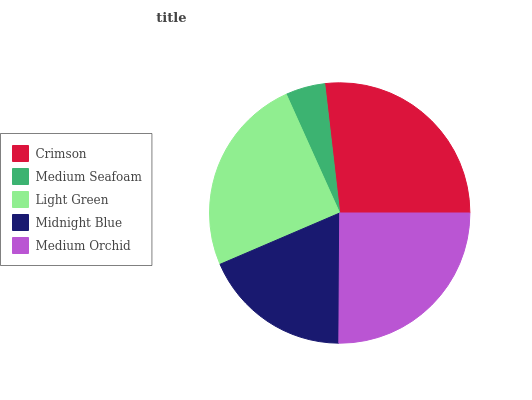Is Medium Seafoam the minimum?
Answer yes or no. Yes. Is Crimson the maximum?
Answer yes or no. Yes. Is Light Green the minimum?
Answer yes or no. No. Is Light Green the maximum?
Answer yes or no. No. Is Light Green greater than Medium Seafoam?
Answer yes or no. Yes. Is Medium Seafoam less than Light Green?
Answer yes or no. Yes. Is Medium Seafoam greater than Light Green?
Answer yes or no. No. Is Light Green less than Medium Seafoam?
Answer yes or no. No. Is Light Green the high median?
Answer yes or no. Yes. Is Light Green the low median?
Answer yes or no. Yes. Is Medium Seafoam the high median?
Answer yes or no. No. Is Medium Seafoam the low median?
Answer yes or no. No. 